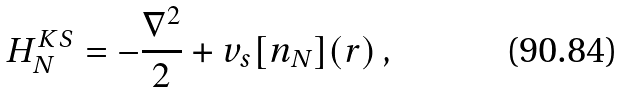Convert formula to latex. <formula><loc_0><loc_0><loc_500><loc_500>H ^ { K S } _ { N } = - \frac { \nabla ^ { 2 } } { 2 } + v _ { s } [ n _ { N } ] ( r ) \, ,</formula> 